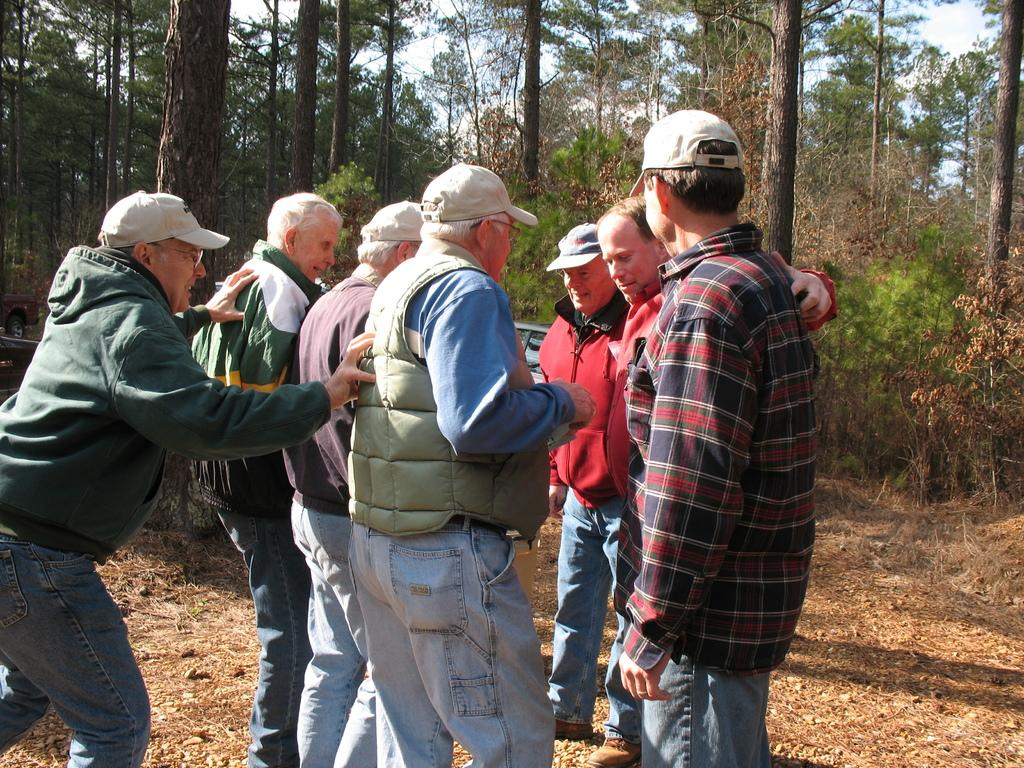How many people are present in the image? There are seven men standing in the image. What is the surface they are standing on? The men are standing on land. What can be seen in the background of the image? There are trees visible in the background of the image. What type of marble is being used as a drink coaster in the image? There is no marble or drink coaster present in the image. What kind of pet can be seen interacting with the men in the image? There is no pet present in the image; only the seven men are visible. 